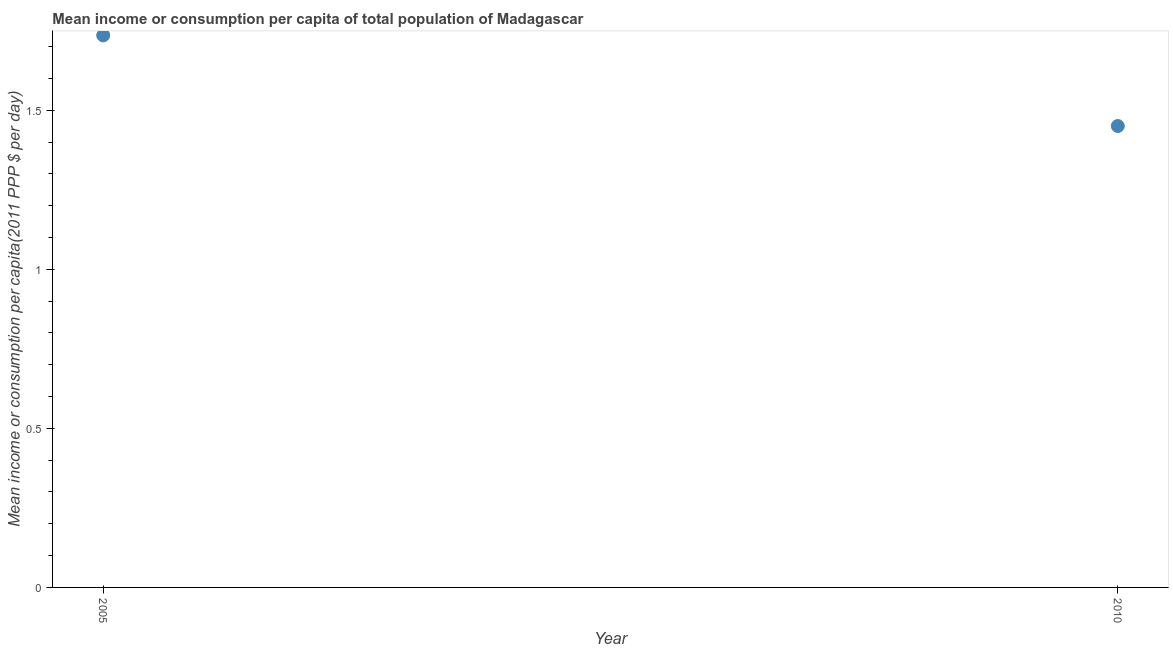What is the mean income or consumption in 2010?
Give a very brief answer. 1.45. Across all years, what is the maximum mean income or consumption?
Give a very brief answer. 1.74. Across all years, what is the minimum mean income or consumption?
Keep it short and to the point. 1.45. In which year was the mean income or consumption maximum?
Give a very brief answer. 2005. In which year was the mean income or consumption minimum?
Your answer should be compact. 2010. What is the sum of the mean income or consumption?
Your answer should be very brief. 3.19. What is the difference between the mean income or consumption in 2005 and 2010?
Your response must be concise. 0.28. What is the average mean income or consumption per year?
Ensure brevity in your answer.  1.59. What is the median mean income or consumption?
Make the answer very short. 1.59. Do a majority of the years between 2005 and 2010 (inclusive) have mean income or consumption greater than 0.2 $?
Ensure brevity in your answer.  Yes. What is the ratio of the mean income or consumption in 2005 to that in 2010?
Ensure brevity in your answer.  1.2. Is the mean income or consumption in 2005 less than that in 2010?
Make the answer very short. No. In how many years, is the mean income or consumption greater than the average mean income or consumption taken over all years?
Keep it short and to the point. 1. Does the mean income or consumption monotonically increase over the years?
Keep it short and to the point. No. How many dotlines are there?
Keep it short and to the point. 1. How many years are there in the graph?
Give a very brief answer. 2. What is the difference between two consecutive major ticks on the Y-axis?
Your answer should be very brief. 0.5. Does the graph contain any zero values?
Make the answer very short. No. Does the graph contain grids?
Your answer should be very brief. No. What is the title of the graph?
Your answer should be compact. Mean income or consumption per capita of total population of Madagascar. What is the label or title of the Y-axis?
Ensure brevity in your answer.  Mean income or consumption per capita(2011 PPP $ per day). What is the Mean income or consumption per capita(2011 PPP $ per day) in 2005?
Provide a short and direct response. 1.74. What is the Mean income or consumption per capita(2011 PPP $ per day) in 2010?
Your answer should be very brief. 1.45. What is the difference between the Mean income or consumption per capita(2011 PPP $ per day) in 2005 and 2010?
Your answer should be compact. 0.28. What is the ratio of the Mean income or consumption per capita(2011 PPP $ per day) in 2005 to that in 2010?
Ensure brevity in your answer.  1.2. 